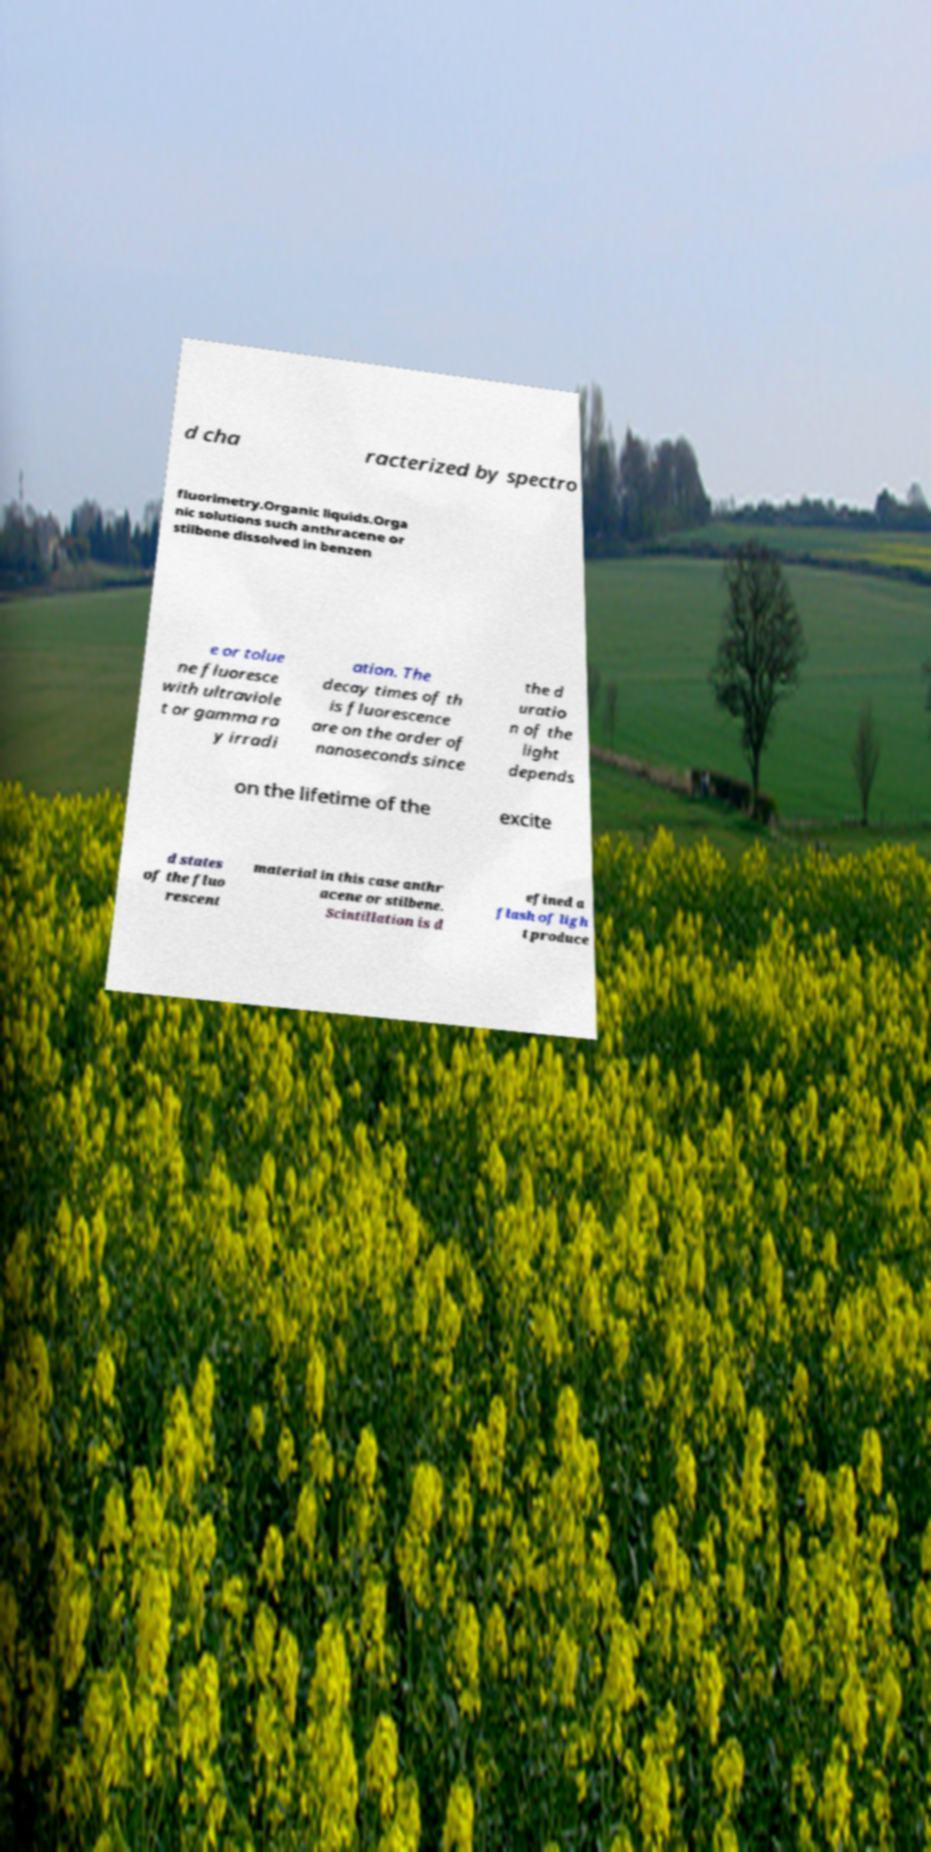Can you read and provide the text displayed in the image?This photo seems to have some interesting text. Can you extract and type it out for me? d cha racterized by spectro fluorimetry.Organic liquids.Orga nic solutions such anthracene or stilbene dissolved in benzen e or tolue ne fluoresce with ultraviole t or gamma ra y irradi ation. The decay times of th is fluorescence are on the order of nanoseconds since the d uratio n of the light depends on the lifetime of the excite d states of the fluo rescent material in this case anthr acene or stilbene. Scintillation is d efined a flash of ligh t produce 